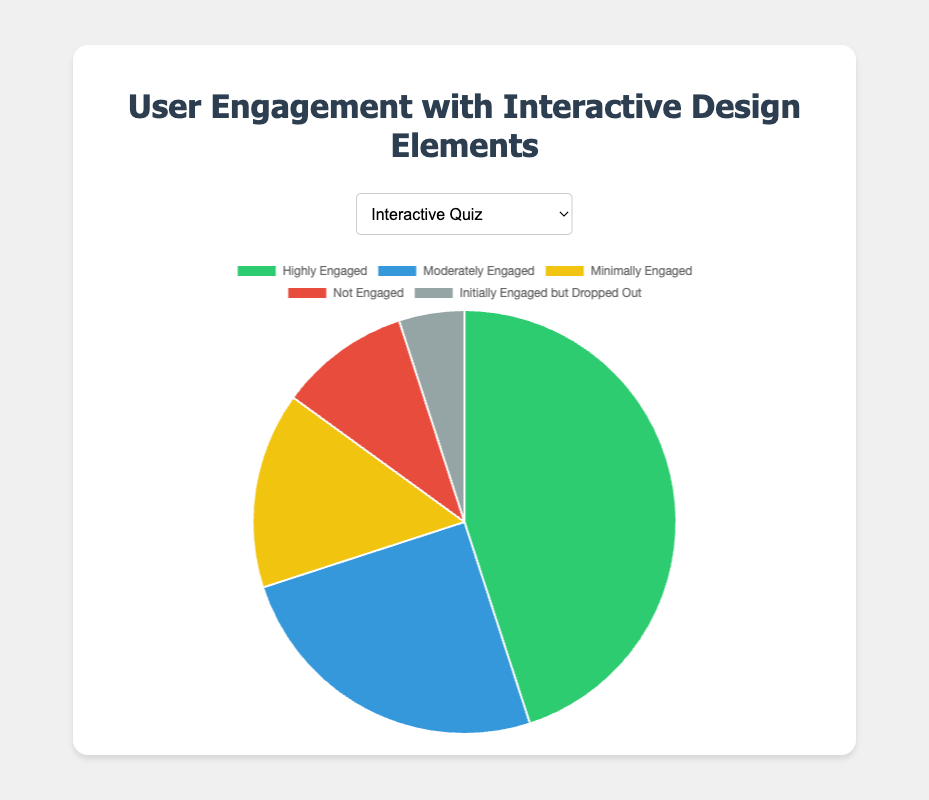What percentage of users are highly engaged with Interactive Quiz? The "Highly Engaged" segment for "Interactive Quiz" is 45 out of 100 total. Therefore, the percentage is (45 / 100) * 100 = 45%.
Answer: 45% Which interactive element has the highest percentage of moderately engaged users? Comparing all elements' "Moderately Engaged" categories, "Interactive Infographic" has 35, which is the highest among the others.
Answer: Interactive Infographic What is the total number of minimally engaged users across all interactive elements? Summing up the "Minimally Engaged" values for each element: 15 (Quiz) + 20 (Infographic) + 10 (Prototypes) + 20 (Drag-and-Drop) + 15 (Tours) = 80.
Answer: 80 Which engagement level has the least number of users in the Drag-and-Drop Activities element? For "Drag-and-Drop Activities," compare the values: 35 (Highly Engaged), 25 (Moderately Engaged), 20 (Minimally Engaged), 15 (Not Engaged), 5 (Initially Engaged but Dropped Out). The smallest value is 5.
Answer: Initially Engaged but Dropped Out How many more users are highly engaged with Virtual Tours compared to Clickable Prototypes? Subtract the "Highly Engaged" values: 50 (Virtual Tours) - 40 (Clickable Prototypes) = 10.
Answer: 10 What is the average percentage of users who were not engaged across all elements? Take the "Not Engaged" values: 10 (Quiz) + 10 (Infographic) + 10 (Prototypes) + 15 (Drag-and-Drop) + 10 (Tours) = 55. Average percentage = (55 / 5) = 11%.
Answer: 11% What is the difference in the number of users initially engaged but dropped out between Interactive Quiz and Clickable Prototypes? Subtract the "Initially Engaged but Dropped Out" values: 10 (Prototypes) - 5 (Quiz) = 5.
Answer: 5 Which engagement level has the highest number of users overall? Sum the values for each engagement level across all elements and compare. Highly Engaged: 45 + 30 + 40 + 35 + 50 = 200, Moderately Engaged: 25 + 35 + 30 + 25 + 20 = 135, Minimally Engaged: 15 + 20 + 10 + 20 + 15 = 80, Not Engaged: 10 + 10 + 10 + 15 + 10 = 55, Initially Engaged but Dropped Out: 5 + 5 + 10 + 5 + 5 = 30. "Highly Engaged" has the highest with 200 users.
Answer: Highly Engaged 